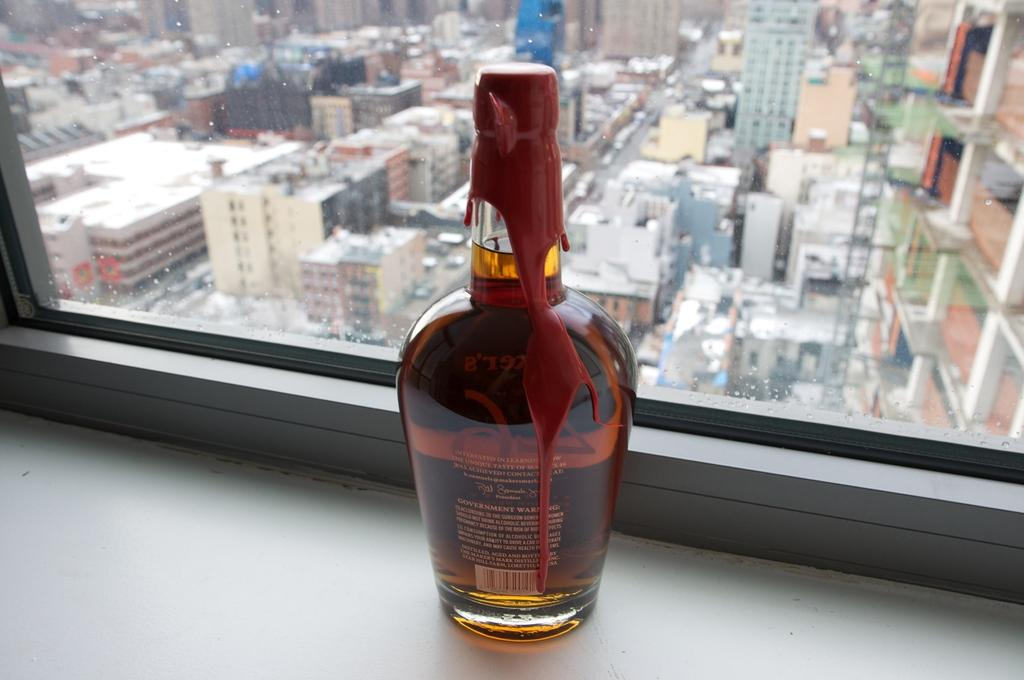What is located near the window in the image? There is a wine bottle in the image, and it is at a window. What can be seen through the window glass in the image? Buildings and poles are visible through the window glass in the image. What is the condition of the window glass in the image? Window glass is visible in the image. What type of jeans is the person wearing in the image? There is no person wearing jeans in the image; it only features a wine bottle at a window with buildings and poles visible through the window glass. 